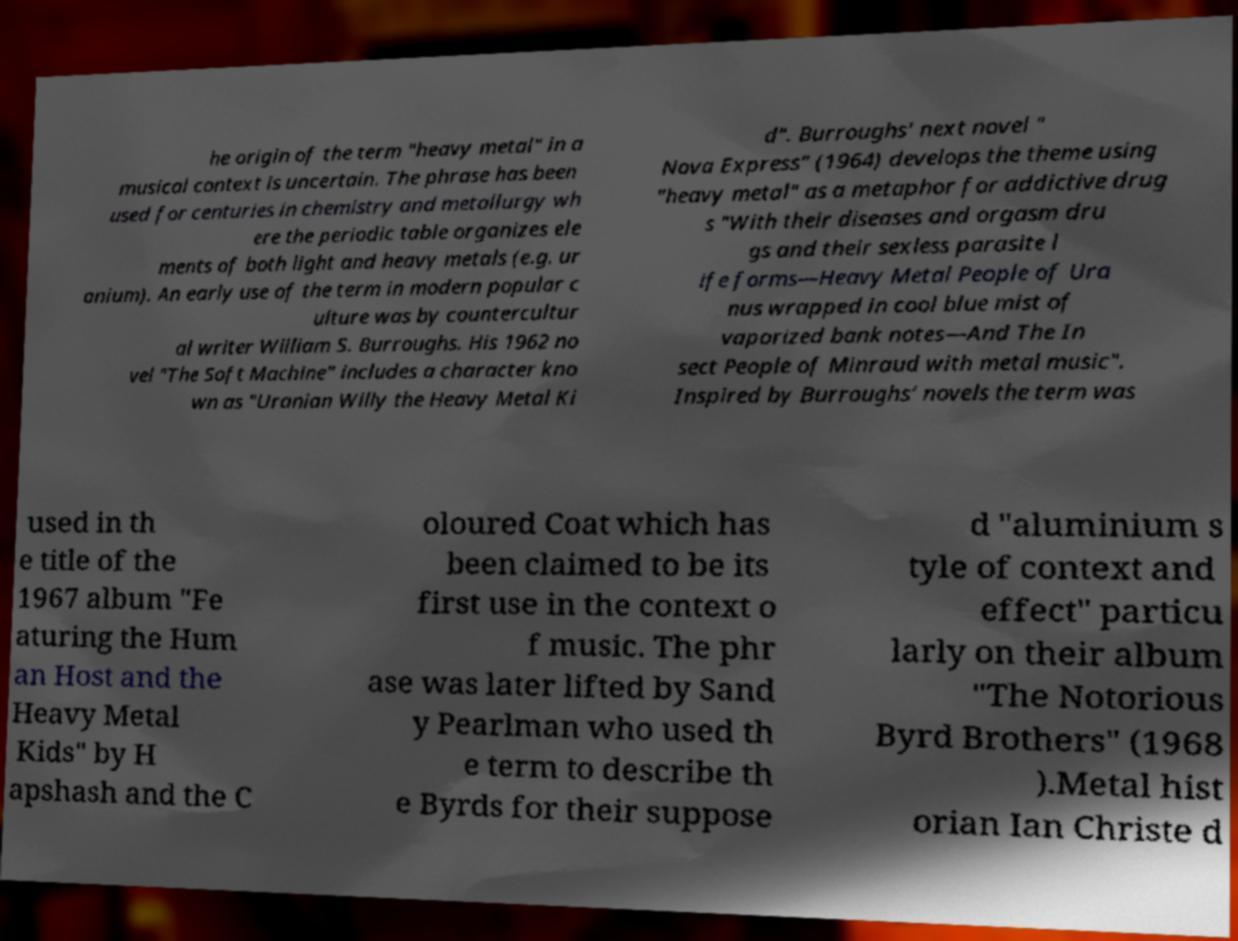Please read and relay the text visible in this image. What does it say? he origin of the term "heavy metal" in a musical context is uncertain. The phrase has been used for centuries in chemistry and metallurgy wh ere the periodic table organizes ele ments of both light and heavy metals (e.g. ur anium). An early use of the term in modern popular c ulture was by countercultur al writer William S. Burroughs. His 1962 no vel "The Soft Machine" includes a character kno wn as "Uranian Willy the Heavy Metal Ki d". Burroughs' next novel " Nova Express" (1964) develops the theme using "heavy metal" as a metaphor for addictive drug s "With their diseases and orgasm dru gs and their sexless parasite l ife forms—Heavy Metal People of Ura nus wrapped in cool blue mist of vaporized bank notes—And The In sect People of Minraud with metal music". Inspired by Burroughs' novels the term was used in th e title of the 1967 album "Fe aturing the Hum an Host and the Heavy Metal Kids" by H apshash and the C oloured Coat which has been claimed to be its first use in the context o f music. The phr ase was later lifted by Sand y Pearlman who used th e term to describe th e Byrds for their suppose d "aluminium s tyle of context and effect" particu larly on their album "The Notorious Byrd Brothers" (1968 ).Metal hist orian Ian Christe d 